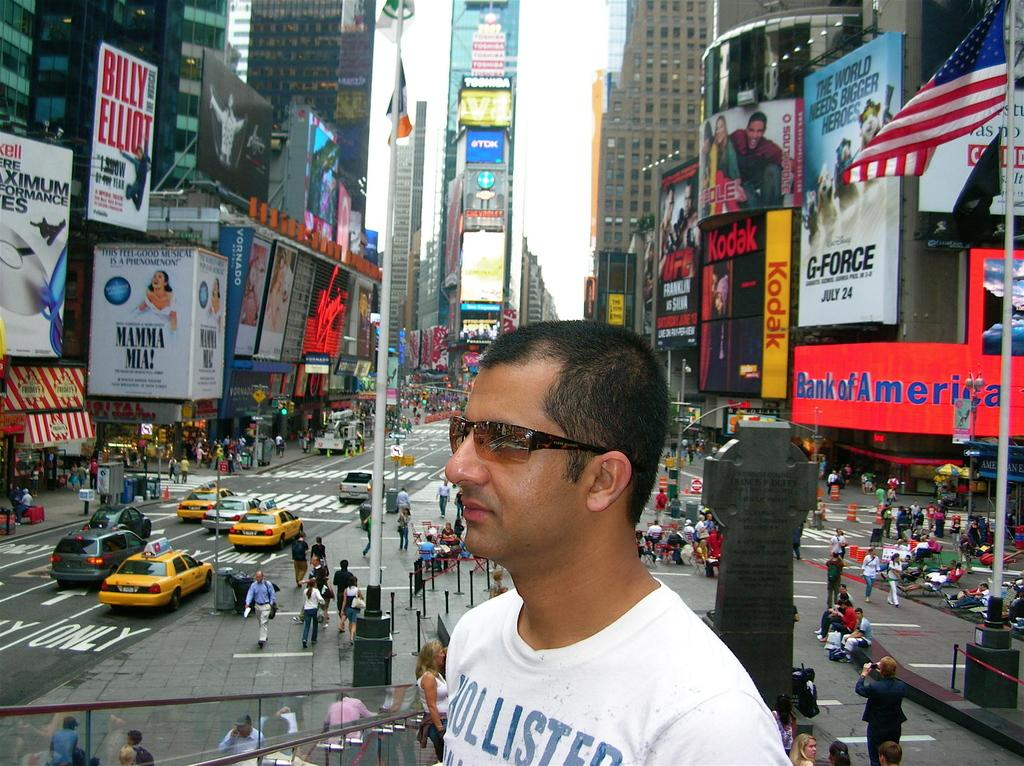<image>
Share a concise interpretation of the image provided. a shirt that has the word Hollister on it 